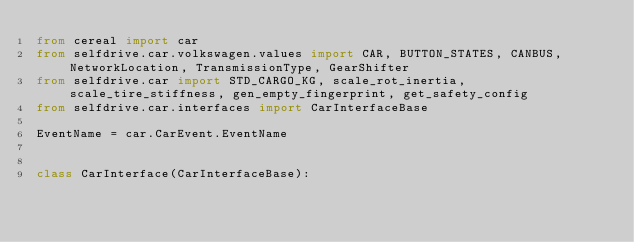Convert code to text. <code><loc_0><loc_0><loc_500><loc_500><_Python_>from cereal import car
from selfdrive.car.volkswagen.values import CAR, BUTTON_STATES, CANBUS, NetworkLocation, TransmissionType, GearShifter
from selfdrive.car import STD_CARGO_KG, scale_rot_inertia, scale_tire_stiffness, gen_empty_fingerprint, get_safety_config
from selfdrive.car.interfaces import CarInterfaceBase

EventName = car.CarEvent.EventName


class CarInterface(CarInterfaceBase):</code> 